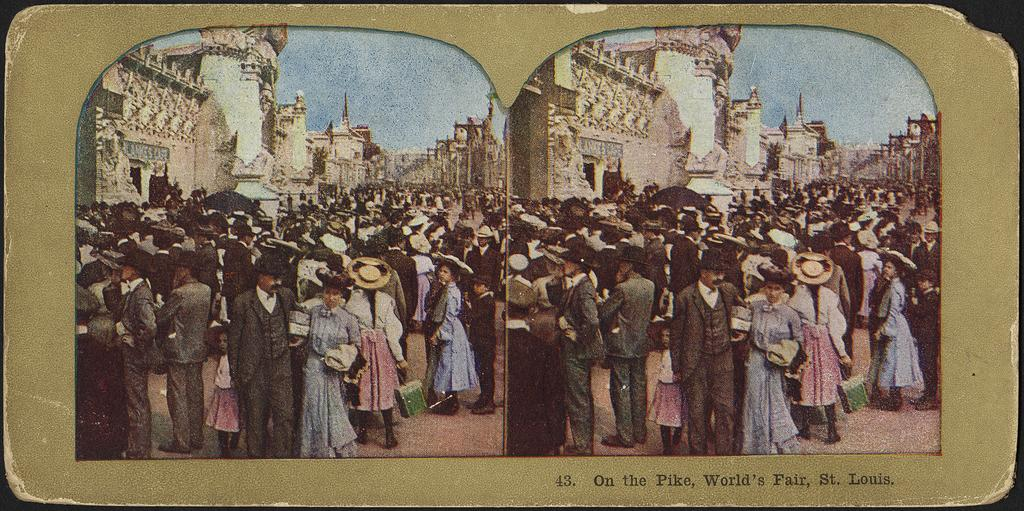<image>
Give a short and clear explanation of the subsequent image. Two duplicate images from the St. Louis World's Fair are side by side on a card. 